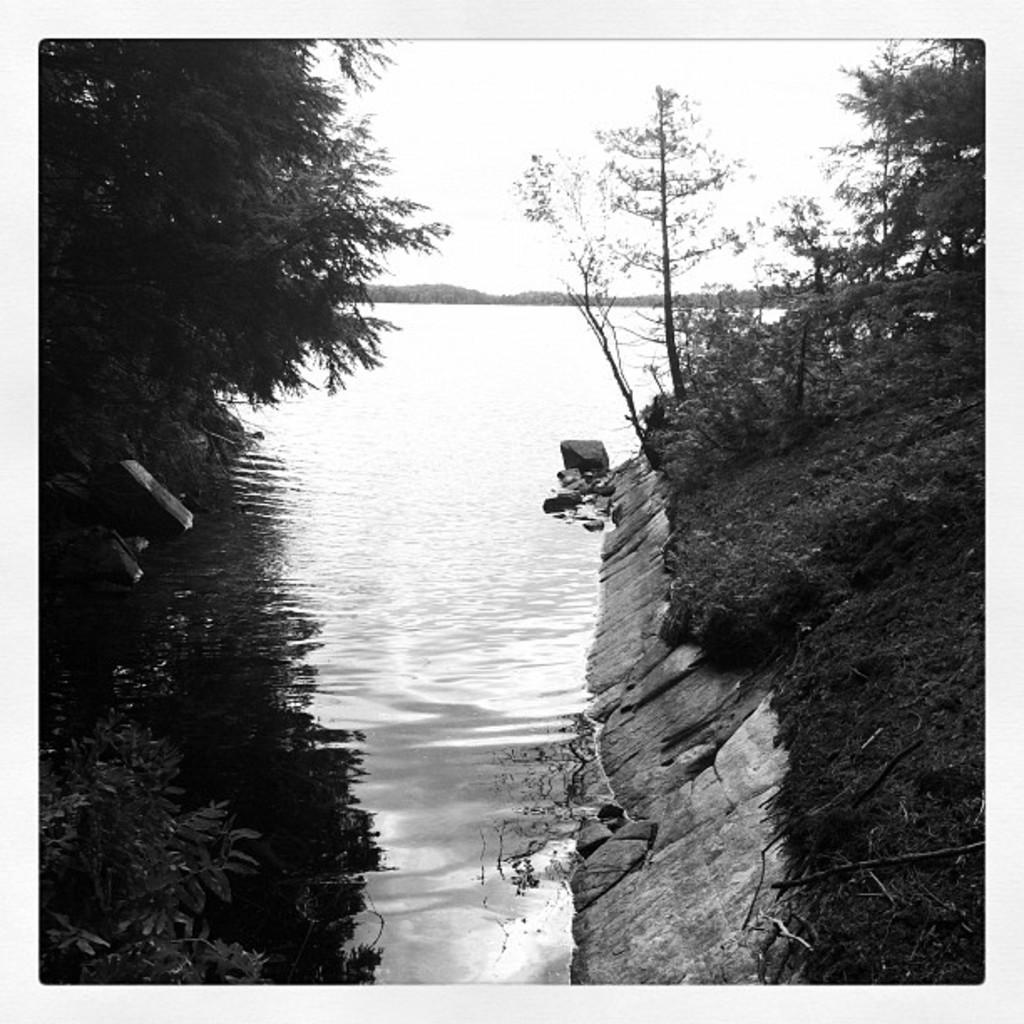Describe this image in one or two sentences. In this image I can see many trees and the rocks. In-between them I can see the water. In the background I can see the sky. 